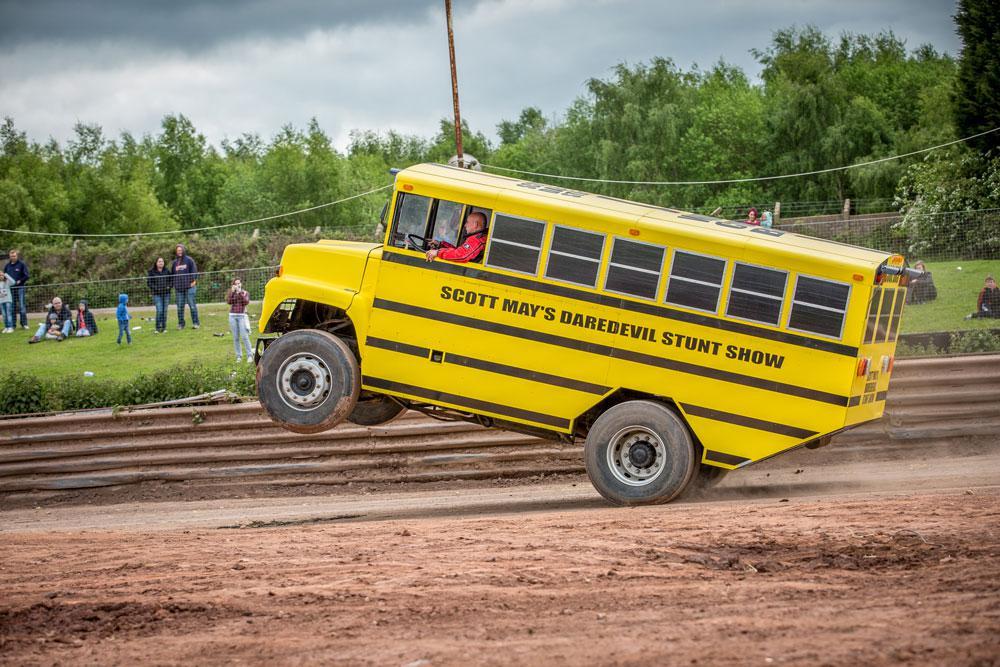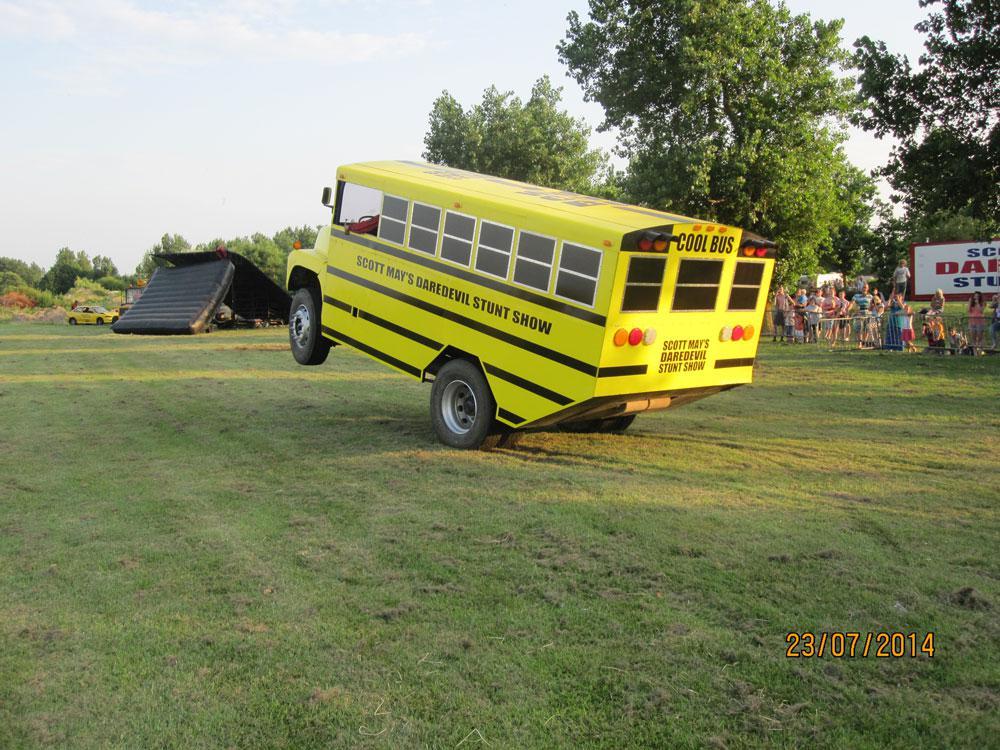The first image is the image on the left, the second image is the image on the right. Analyze the images presented: Is the assertion "The right image contains a school bus that is airborne being launched over objects." valid? Answer yes or no. No. The first image is the image on the left, the second image is the image on the right. Analyze the images presented: Is the assertion "Both images feature buses performing stunts, and at least one image shows a yellow bus performing a wheelie with front wheels off the ground." valid? Answer yes or no. Yes. 